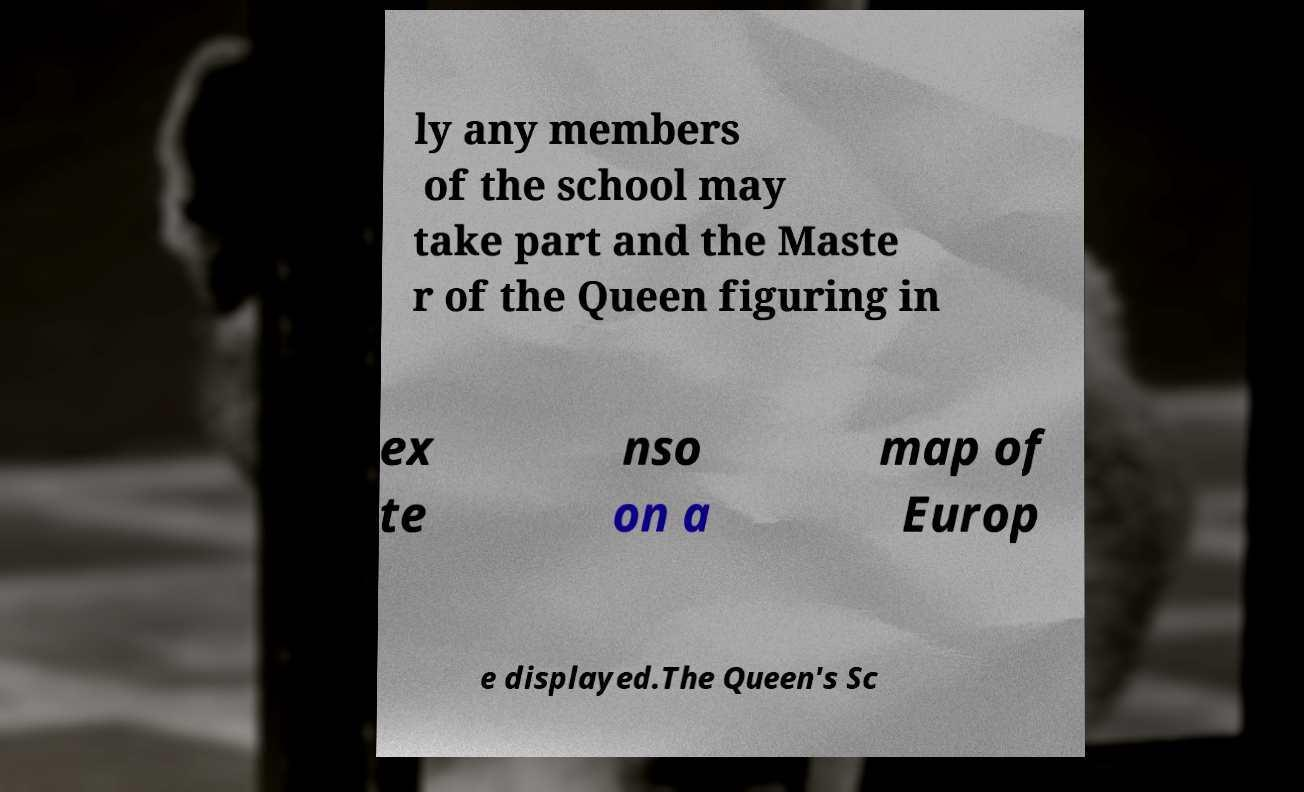Can you accurately transcribe the text from the provided image for me? ly any members of the school may take part and the Maste r of the Queen figuring in ex te nso on a map of Europ e displayed.The Queen's Sc 